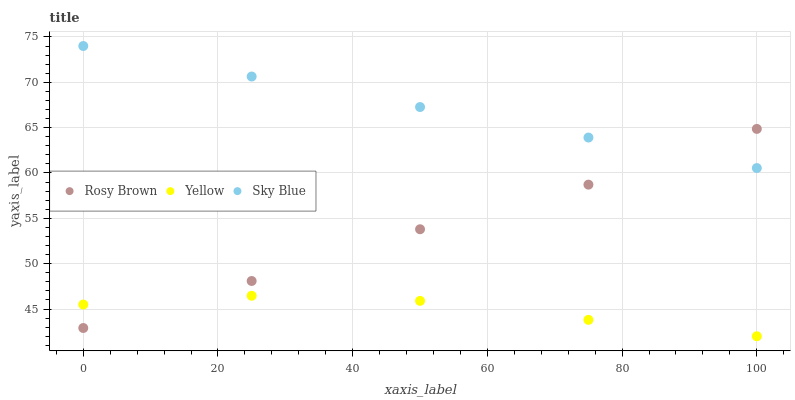Does Yellow have the minimum area under the curve?
Answer yes or no. Yes. Does Sky Blue have the maximum area under the curve?
Answer yes or no. Yes. Does Rosy Brown have the minimum area under the curve?
Answer yes or no. No. Does Rosy Brown have the maximum area under the curve?
Answer yes or no. No. Is Sky Blue the smoothest?
Answer yes or no. Yes. Is Yellow the roughest?
Answer yes or no. Yes. Is Rosy Brown the smoothest?
Answer yes or no. No. Is Rosy Brown the roughest?
Answer yes or no. No. Does Yellow have the lowest value?
Answer yes or no. Yes. Does Rosy Brown have the lowest value?
Answer yes or no. No. Does Sky Blue have the highest value?
Answer yes or no. Yes. Does Rosy Brown have the highest value?
Answer yes or no. No. Is Yellow less than Sky Blue?
Answer yes or no. Yes. Is Sky Blue greater than Yellow?
Answer yes or no. Yes. Does Rosy Brown intersect Sky Blue?
Answer yes or no. Yes. Is Rosy Brown less than Sky Blue?
Answer yes or no. No. Is Rosy Brown greater than Sky Blue?
Answer yes or no. No. Does Yellow intersect Sky Blue?
Answer yes or no. No. 